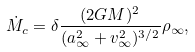<formula> <loc_0><loc_0><loc_500><loc_500>\dot { M } _ { c } = \delta \frac { ( 2 G M ) ^ { 2 } } { ( a ^ { 2 } _ { \infty } + v ^ { 2 } _ { \infty } ) ^ { 3 / 2 } } \rho _ { \infty } ,</formula> 